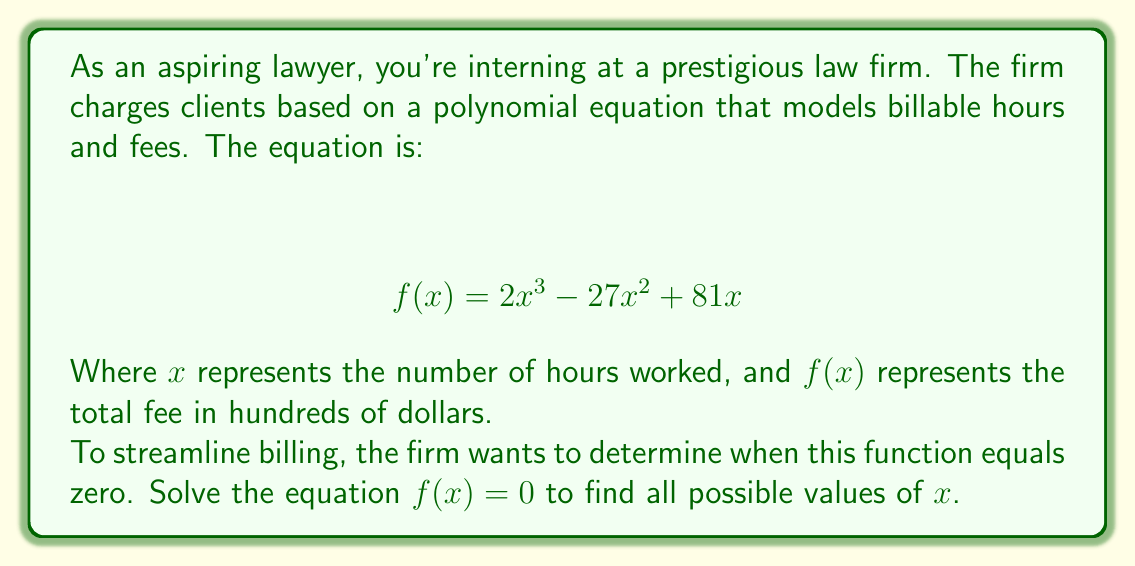Show me your answer to this math problem. Let's approach this step-by-step:

1) We start with the equation:
   $$ 2x^3 - 27x^2 + 81x = 0 $$

2) Factor out the greatest common factor:
   $$ x(2x^2 - 27x + 81) = 0 $$

3) This gives us two factors. Either $x = 0$ or $2x^2 - 27x + 81 = 0$

4) For the quadratic factor, we can use the quadratic formula or factoring. Let's factor:
   $$ 2x^2 - 27x + 81 = (2x - 9)(x - 9) $$

5) So our equation becomes:
   $$ x(2x - 9)(x - 9) = 0 $$

6) By the zero product property, if the product of factors is zero, at least one factor must be zero. So we solve:

   $x = 0$ or $2x - 9 = 0$ or $x - 9 = 0$

7) Solving these:
   $x = 0$ or $x = \frac{9}{2}$ or $x = 9$

Therefore, the equation is satisfied when $x = 0$, $x = \frac{9}{2}$, or $x = 9$.
Answer: The solutions are $x = 0$, $x = \frac{9}{2}$, and $x = 9$. 